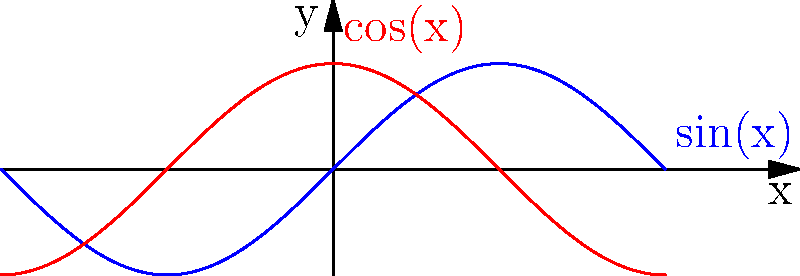As a web developer using jQuery and Plupload, you want to create a smooth wave animation effect for a background element. Which CSS property should you animate using sine and cosine functions to achieve this effect, and how would you implement it using jQuery? To create a smooth wave animation effect using sine and cosine functions in CSS, follow these steps:

1. The key CSS property to animate for a wave effect is `transform: translateY()`.

2. Use sine and cosine functions to create the wave motion:
   - Sine function: $y = A \sin(kx - \omega t)$
   - Cosine function: $y = A \cos(kx - \omega t)$
   Where:
   $A$ is the amplitude
   $k$ is the wave number
   $x$ is the horizontal position
   $\omega$ is the angular frequency
   $t$ is time

3. Implement the animation using jQuery:
   ```javascript
   $(function() {
     const amplitude = 20; // pixels
     const frequency = 0.02; // adjust for speed
     const elements = $('.wave-element');
     
     function animate() {
       const time = Date.now() * 0.001; // convert to seconds
       elements.each(function(index) {
         const x = index * 50; // horizontal spacing
         const y = amplitude * Math.sin(frequency * x - time);
         $(this).css('transform', `translateY(${y}px)`);
       });
       requestAnimationFrame(animate);
     }
     
     animate();
   });
   ```

4. This code creates a wave effect by:
   - Applying a unique `translateY` value to each element
   - Using `Math.sin()` to calculate the y-position
   - Continuously updating the position using `requestAnimationFrame`

5. To add more complexity, you can combine sine and cosine:
   ```javascript
   const y = amplitude * (Math.sin(frequency * x - time) + Math.cos(frequency * x - time * 0.5));
   ```

This implementation creates a smooth, continuous wave animation effect using trigonometric functions.
Answer: Animate `transform: translateY()` using `Math.sin()` and `Math.cos()` with jQuery's `.css()` method and `requestAnimationFrame`. 